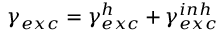Convert formula to latex. <formula><loc_0><loc_0><loc_500><loc_500>\gamma _ { e x c } = \gamma _ { e x c } ^ { h } + \gamma _ { e x c } ^ { i n h }</formula> 